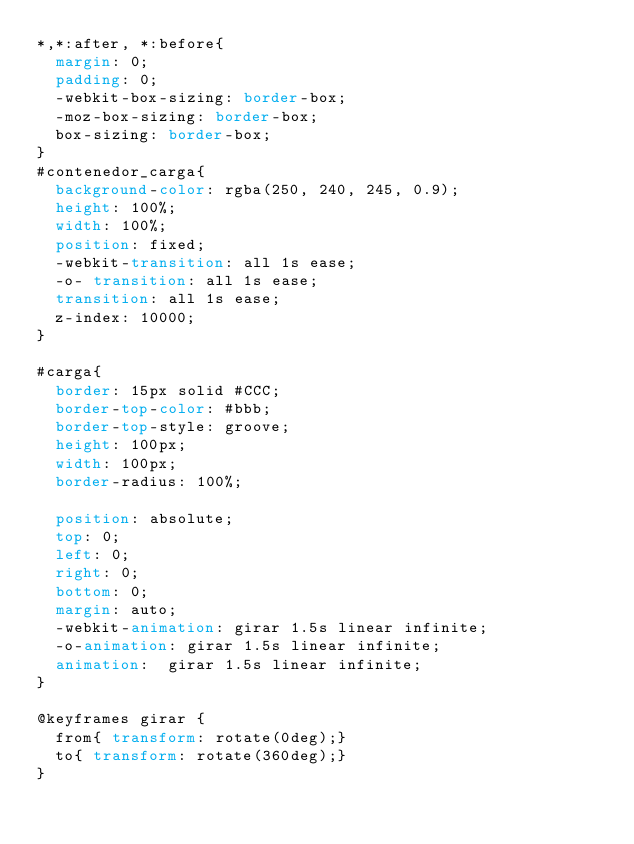<code> <loc_0><loc_0><loc_500><loc_500><_CSS_>*,*:after, *:before{
  margin: 0;
  padding: 0;
  -webkit-box-sizing: border-box;
  -moz-box-sizing: border-box;
  box-sizing: border-box;
}
#contenedor_carga{
  background-color: rgba(250, 240, 245, 0.9);
  height: 100%;
  width: 100%;
  position: fixed;
  -webkit-transition: all 1s ease;
  -o- transition: all 1s ease;
  transition: all 1s ease;
  z-index: 10000;
}

#carga{
  border: 15px solid #CCC;
  border-top-color: #bbb;
  border-top-style: groove;
  height: 100px;
  width: 100px;
  border-radius: 100%;

  position: absolute;
  top: 0;
  left: 0;
  right: 0;
  bottom: 0;
  margin: auto;
  -webkit-animation: girar 1.5s linear infinite;
  -o-animation: girar 1.5s linear infinite;
  animation:  girar 1.5s linear infinite;
}

@keyframes girar {
  from{ transform: rotate(0deg);}
  to{ transform: rotate(360deg);}
}
</code> 